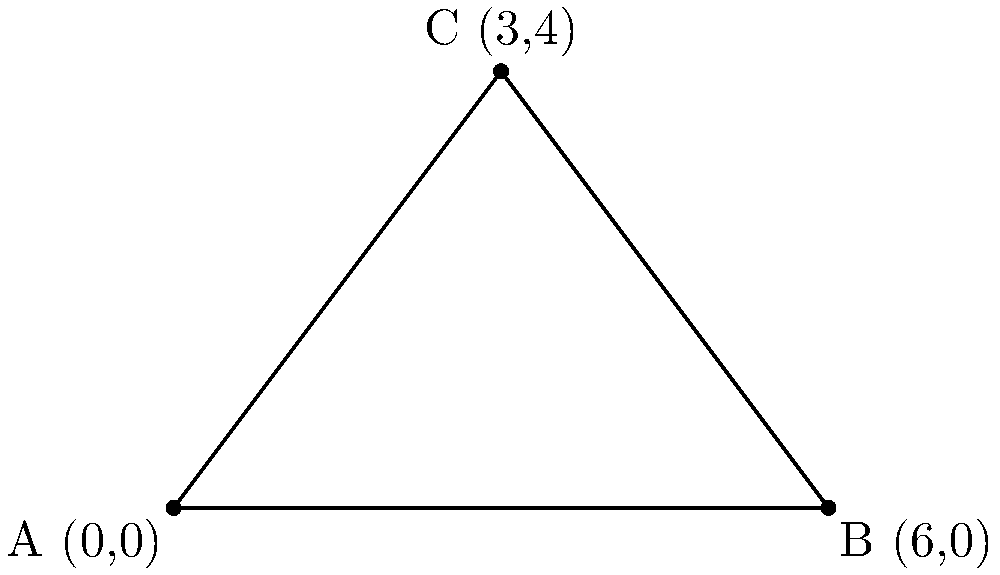In a new Nollywood movie featuring a strong female lead, three filming locations are represented by the points A(0,0), B(6,0), and C(3,4) on a coordinate plane. These points form a triangle representing the area where most of the movie's scenes will be shot. Calculate the area of this triangle to determine the total filming space available for the production. To find the area of the triangle formed by the three points, we can use the formula:

$$\text{Area} = \frac{1}{2}|x_1(y_2 - y_3) + x_2(y_3 - y_1) + x_3(y_1 - y_2)|$$

Where $(x_1, y_1)$, $(x_2, y_2)$, and $(x_3, y_3)$ are the coordinates of the three points.

Step 1: Identify the coordinates
A: $(x_1, y_1) = (0, 0)$
B: $(x_2, y_2) = (6, 0)$
C: $(x_3, y_3) = (3, 4)$

Step 2: Substitute the values into the formula
$$\text{Area} = \frac{1}{2}|0(0 - 4) + 6(4 - 0) + 3(0 - 0)|$$

Step 3: Simplify
$$\text{Area} = \frac{1}{2}|0 + 24 + 0|$$
$$\text{Area} = \frac{1}{2}|24|$$
$$\text{Area} = \frac{1}{2} \times 24$$

Step 4: Calculate the final result
$$\text{Area} = 12$$

Therefore, the area of the triangle representing the filming space is 12 square units.
Answer: 12 square units 